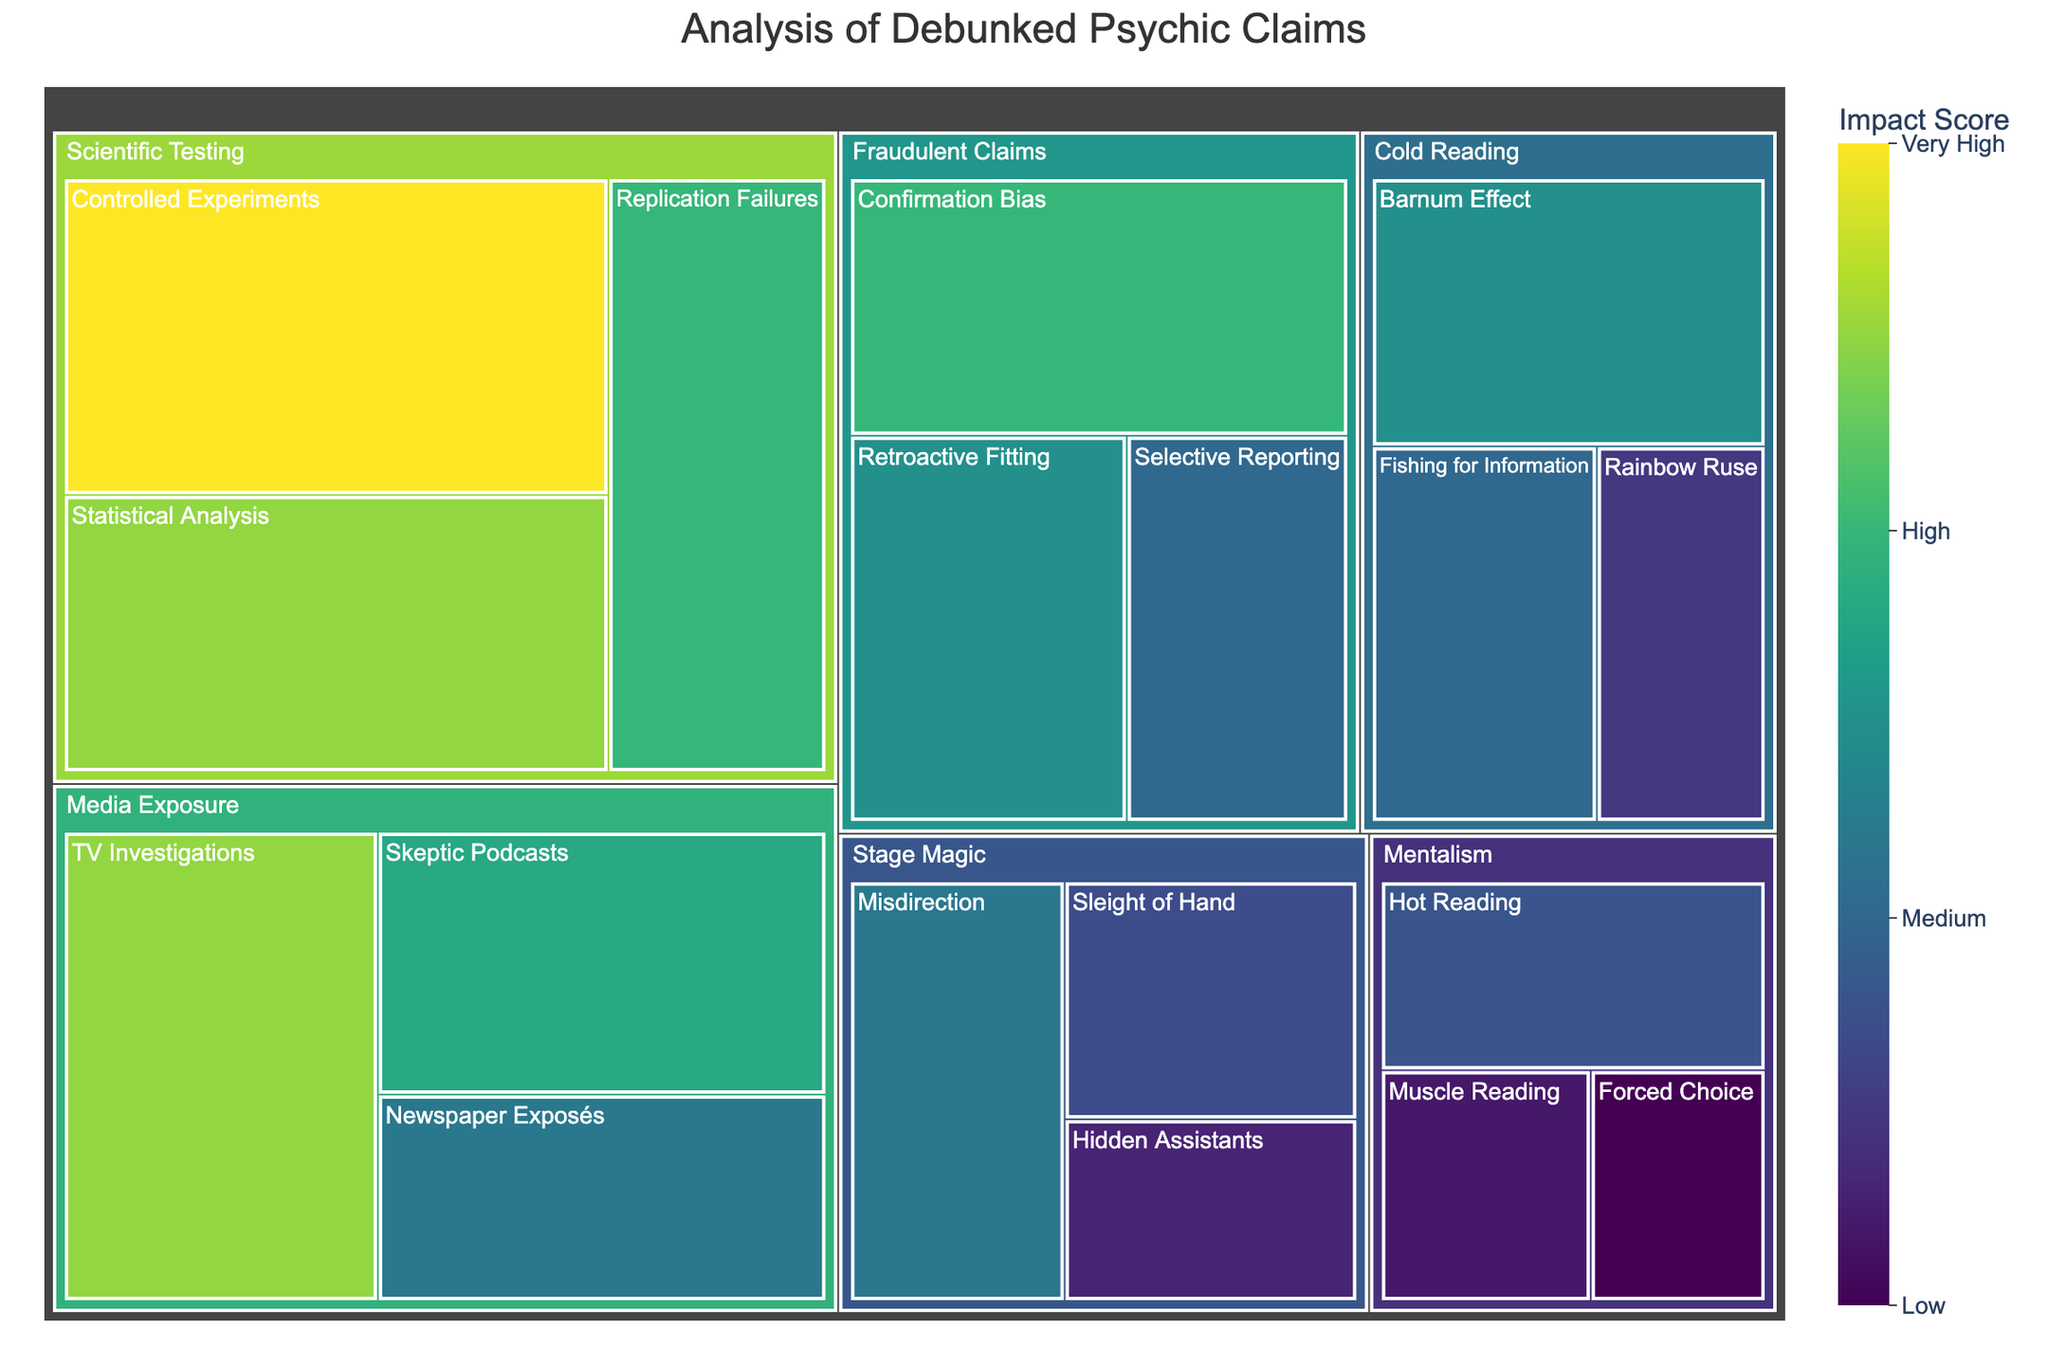what is the title of the treemap? The title is displayed at the top of the treemap in large font. By reading this text, we can determine the title provided for the visualization.
Answer: Analysis of Debunked Psychic Claims Which subcategory has the highest impact score? To find the subcategory with the highest impact score, look at the values labeled on the subcategories. Identify the subcategory with the largest number.
Answer: Controlled Experiments What is the total impact score for the methods under "Cold Reading"? To find the total impact score for "Cold Reading," sum the values of all its subcategories: Barnum Effect (25), Fishing for Information (20), and Rainbow Ruse (15). These values are listed under the "Cold Reading" category.
Answer: 60 Which has a greater impact score: "Media Exposure" or "Stage Magic"? Compare the total impact scores of the subcategories under "Media Exposure" (TV Investigations, Skeptic Podcasts, Newspaper Exposés) and "Stage Magic" (Misdirection, Sleight of Hand, Hidden Assistants).
Answer: Media Exposure What is the average impact score of the subcategories under "Fraudulent Claims"? To calculate the average impact score for "Fraudulent Claims," sum the impact values for Confirmation Bias (30), Retroactive Fitting (25), and Selective Reporting (20), then divide by the number of subcategories (3).
Answer: 25 Which method under "Scientific Testing" has the lowest impact score? Analyze the values for each subcategory under "Scientific Testing" and identify the one with the lowest value.
Answer: Replication Failures How many subcategories fall under the "Mentalism" category, and what is their combined impact score? Count the number of subcategories and sum their values under the "Mentalism" category: Hot Reading, Muscle Reading, and Forced Choice. Sum their values as well.
Answer: 3 subcategories, 40 total impact score Among the subcategories under "Media Exposure," which one has the highest impact score? Look at the values for each subcategory under "Media Exposure" and identify the one with the highest score.
Answer: TV Investigations 